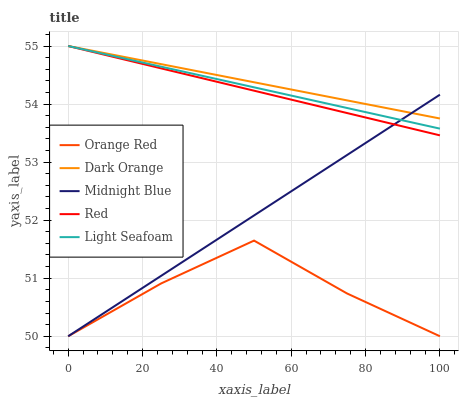Does Light Seafoam have the minimum area under the curve?
Answer yes or no. No. Does Light Seafoam have the maximum area under the curve?
Answer yes or no. No. Is Light Seafoam the smoothest?
Answer yes or no. No. Is Light Seafoam the roughest?
Answer yes or no. No. Does Light Seafoam have the lowest value?
Answer yes or no. No. Does Orange Red have the highest value?
Answer yes or no. No. Is Orange Red less than Red?
Answer yes or no. Yes. Is Light Seafoam greater than Orange Red?
Answer yes or no. Yes. Does Orange Red intersect Red?
Answer yes or no. No. 